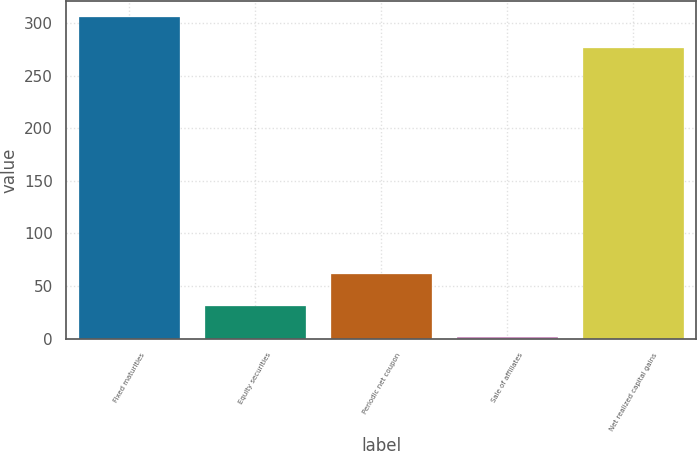<chart> <loc_0><loc_0><loc_500><loc_500><bar_chart><fcel>Fixed maturities<fcel>Equity securities<fcel>Periodic net coupon<fcel>Sale of affiliates<fcel>Net realized capital gains<nl><fcel>305.5<fcel>31.5<fcel>61<fcel>2<fcel>276<nl></chart> 